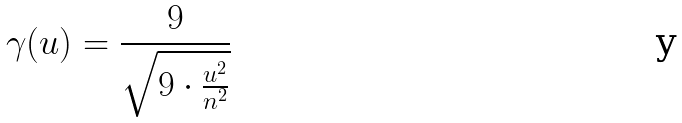Convert formula to latex. <formula><loc_0><loc_0><loc_500><loc_500>\gamma ( u ) = \frac { 9 } { \sqrt { 9 \cdot \frac { u ^ { 2 } } { n ^ { 2 } } } }</formula> 